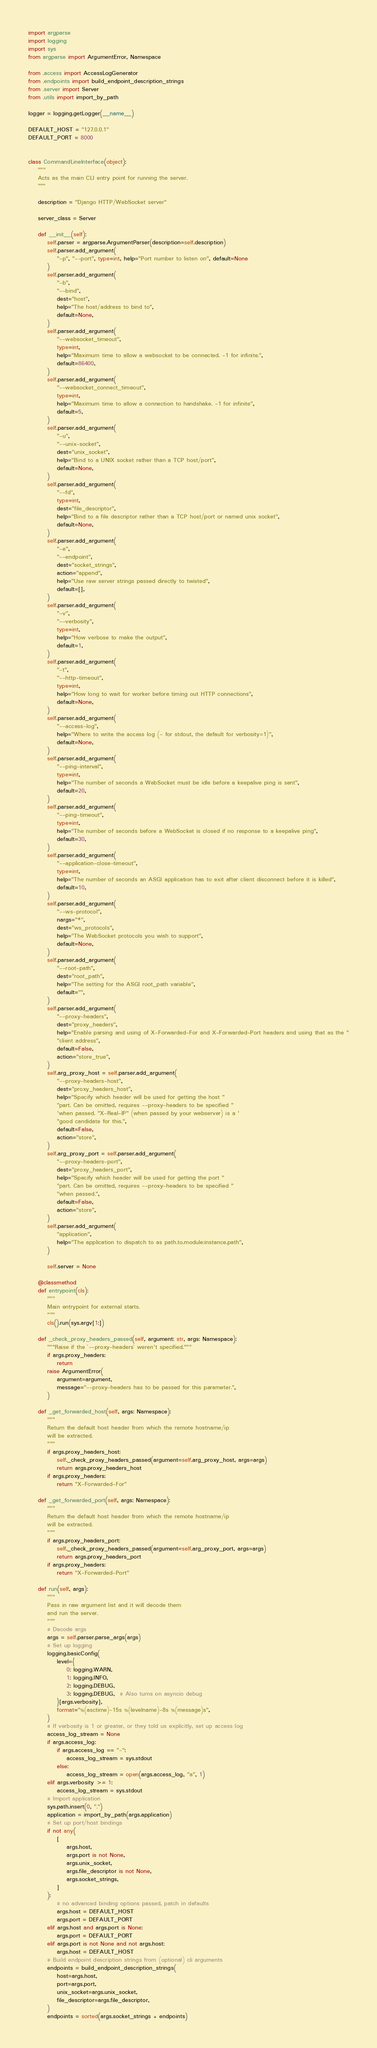<code> <loc_0><loc_0><loc_500><loc_500><_Python_>import argparse
import logging
import sys
from argparse import ArgumentError, Namespace

from .access import AccessLogGenerator
from .endpoints import build_endpoint_description_strings
from .server import Server
from .utils import import_by_path

logger = logging.getLogger(__name__)

DEFAULT_HOST = "127.0.0.1"
DEFAULT_PORT = 8000


class CommandLineInterface(object):
    """
    Acts as the main CLI entry point for running the server.
    """

    description = "Django HTTP/WebSocket server"

    server_class = Server

    def __init__(self):
        self.parser = argparse.ArgumentParser(description=self.description)
        self.parser.add_argument(
            "-p", "--port", type=int, help="Port number to listen on", default=None
        )
        self.parser.add_argument(
            "-b",
            "--bind",
            dest="host",
            help="The host/address to bind to",
            default=None,
        )
        self.parser.add_argument(
            "--websocket_timeout",
            type=int,
            help="Maximum time to allow a websocket to be connected. -1 for infinite.",
            default=86400,
        )
        self.parser.add_argument(
            "--websocket_connect_timeout",
            type=int,
            help="Maximum time to allow a connection to handshake. -1 for infinite",
            default=5,
        )
        self.parser.add_argument(
            "-u",
            "--unix-socket",
            dest="unix_socket",
            help="Bind to a UNIX socket rather than a TCP host/port",
            default=None,
        )
        self.parser.add_argument(
            "--fd",
            type=int,
            dest="file_descriptor",
            help="Bind to a file descriptor rather than a TCP host/port or named unix socket",
            default=None,
        )
        self.parser.add_argument(
            "-e",
            "--endpoint",
            dest="socket_strings",
            action="append",
            help="Use raw server strings passed directly to twisted",
            default=[],
        )
        self.parser.add_argument(
            "-v",
            "--verbosity",
            type=int,
            help="How verbose to make the output",
            default=1,
        )
        self.parser.add_argument(
            "-t",
            "--http-timeout",
            type=int,
            help="How long to wait for worker before timing out HTTP connections",
            default=None,
        )
        self.parser.add_argument(
            "--access-log",
            help="Where to write the access log (- for stdout, the default for verbosity=1)",
            default=None,
        )
        self.parser.add_argument(
            "--ping-interval",
            type=int,
            help="The number of seconds a WebSocket must be idle before a keepalive ping is sent",
            default=20,
        )
        self.parser.add_argument(
            "--ping-timeout",
            type=int,
            help="The number of seconds before a WebSocket is closed if no response to a keepalive ping",
            default=30,
        )
        self.parser.add_argument(
            "--application-close-timeout",
            type=int,
            help="The number of seconds an ASGI application has to exit after client disconnect before it is killed",
            default=10,
        )
        self.parser.add_argument(
            "--ws-protocol",
            nargs="*",
            dest="ws_protocols",
            help="The WebSocket protocols you wish to support",
            default=None,
        )
        self.parser.add_argument(
            "--root-path",
            dest="root_path",
            help="The setting for the ASGI root_path variable",
            default="",
        )
        self.parser.add_argument(
            "--proxy-headers",
            dest="proxy_headers",
            help="Enable parsing and using of X-Forwarded-For and X-Forwarded-Port headers and using that as the "
            "client address",
            default=False,
            action="store_true",
        )
        self.arg_proxy_host = self.parser.add_argument(
            "--proxy-headers-host",
            dest="proxy_headers_host",
            help="Specify which header will be used for getting the host "
            "part. Can be omitted, requires --proxy-headers to be specified "
            'when passed. "X-Real-IP" (when passed by your webserver) is a '
            "good candidate for this.",
            default=False,
            action="store",
        )
        self.arg_proxy_port = self.parser.add_argument(
            "--proxy-headers-port",
            dest="proxy_headers_port",
            help="Specify which header will be used for getting the port "
            "part. Can be omitted, requires --proxy-headers to be specified "
            "when passed.",
            default=False,
            action="store",
        )
        self.parser.add_argument(
            "application",
            help="The application to dispatch to as path.to.module:instance.path",
        )

        self.server = None

    @classmethod
    def entrypoint(cls):
        """
        Main entrypoint for external starts.
        """
        cls().run(sys.argv[1:])

    def _check_proxy_headers_passed(self, argument: str, args: Namespace):
        """Raise if the `--proxy-headers` weren't specified."""
        if args.proxy_headers:
            return
        raise ArgumentError(
            argument=argument,
            message="--proxy-headers has to be passed for this parameter.",
        )

    def _get_forwarded_host(self, args: Namespace):
        """
        Return the default host header from which the remote hostname/ip
        will be extracted.
        """
        if args.proxy_headers_host:
            self._check_proxy_headers_passed(argument=self.arg_proxy_host, args=args)
            return args.proxy_headers_host
        if args.proxy_headers:
            return "X-Forwarded-For"

    def _get_forwarded_port(self, args: Namespace):
        """
        Return the default host header from which the remote hostname/ip
        will be extracted.
        """
        if args.proxy_headers_port:
            self._check_proxy_headers_passed(argument=self.arg_proxy_port, args=args)
            return args.proxy_headers_port
        if args.proxy_headers:
            return "X-Forwarded-Port"

    def run(self, args):
        """
        Pass in raw argument list and it will decode them
        and run the server.
        """
        # Decode args
        args = self.parser.parse_args(args)
        # Set up logging
        logging.basicConfig(
            level={
                0: logging.WARN,
                1: logging.INFO,
                2: logging.DEBUG,
                3: logging.DEBUG,  # Also turns on asyncio debug
            }[args.verbosity],
            format="%(asctime)-15s %(levelname)-8s %(message)s",
        )
        # If verbosity is 1 or greater, or they told us explicitly, set up access log
        access_log_stream = None
        if args.access_log:
            if args.access_log == "-":
                access_log_stream = sys.stdout
            else:
                access_log_stream = open(args.access_log, "a", 1)
        elif args.verbosity >= 1:
            access_log_stream = sys.stdout
        # Import application
        sys.path.insert(0, ".")
        application = import_by_path(args.application)
        # Set up port/host bindings
        if not any(
            [
                args.host,
                args.port is not None,
                args.unix_socket,
                args.file_descriptor is not None,
                args.socket_strings,
            ]
        ):
            # no advanced binding options passed, patch in defaults
            args.host = DEFAULT_HOST
            args.port = DEFAULT_PORT
        elif args.host and args.port is None:
            args.port = DEFAULT_PORT
        elif args.port is not None and not args.host:
            args.host = DEFAULT_HOST
        # Build endpoint description strings from (optional) cli arguments
        endpoints = build_endpoint_description_strings(
            host=args.host,
            port=args.port,
            unix_socket=args.unix_socket,
            file_descriptor=args.file_descriptor,
        )
        endpoints = sorted(args.socket_strings + endpoints)</code> 